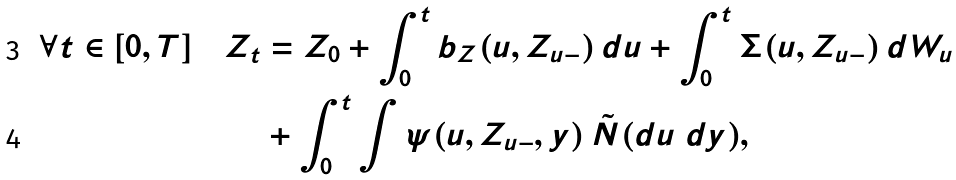Convert formula to latex. <formula><loc_0><loc_0><loc_500><loc_500>\forall t \in [ 0 , T ] \quad Z _ { t } & = Z _ { 0 } + \int _ { 0 } ^ { t } b _ { Z } ( u , Z _ { u - } ) \, d u + \int _ { 0 } ^ { t } \Sigma ( u , Z _ { u - } ) \, d W _ { u } \\ & + \int _ { 0 } ^ { t } \int \psi ( u , Z _ { u - } , y ) \, \tilde { N } ( d u \ d y ) ,</formula> 